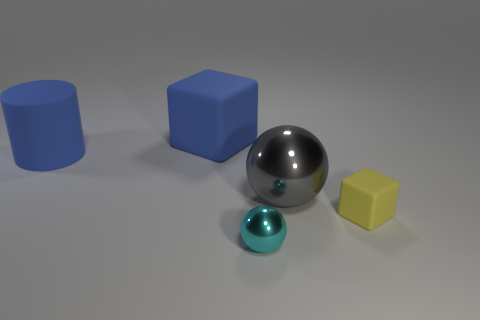Is there any other thing that has the same size as the matte cylinder?
Provide a succinct answer. Yes. Do the cyan thing and the cube in front of the big sphere have the same size?
Offer a terse response. Yes. What number of big rubber cylinders are there?
Keep it short and to the point. 1. Is the size of the metallic thing that is in front of the gray object the same as the blue rubber object that is in front of the blue matte cube?
Provide a short and direct response. No. What color is the big thing that is the same shape as the tiny shiny object?
Your answer should be very brief. Gray. Does the cyan shiny object have the same shape as the yellow matte object?
Your answer should be compact. No. There is another thing that is the same shape as the gray shiny object; what size is it?
Offer a very short reply. Small. How many tiny cubes have the same material as the big cube?
Provide a succinct answer. 1. How many objects are large gray blocks or large gray shiny balls?
Make the answer very short. 1. Is there a blue cylinder that is to the right of the matte cube that is to the right of the small cyan thing?
Keep it short and to the point. No. 